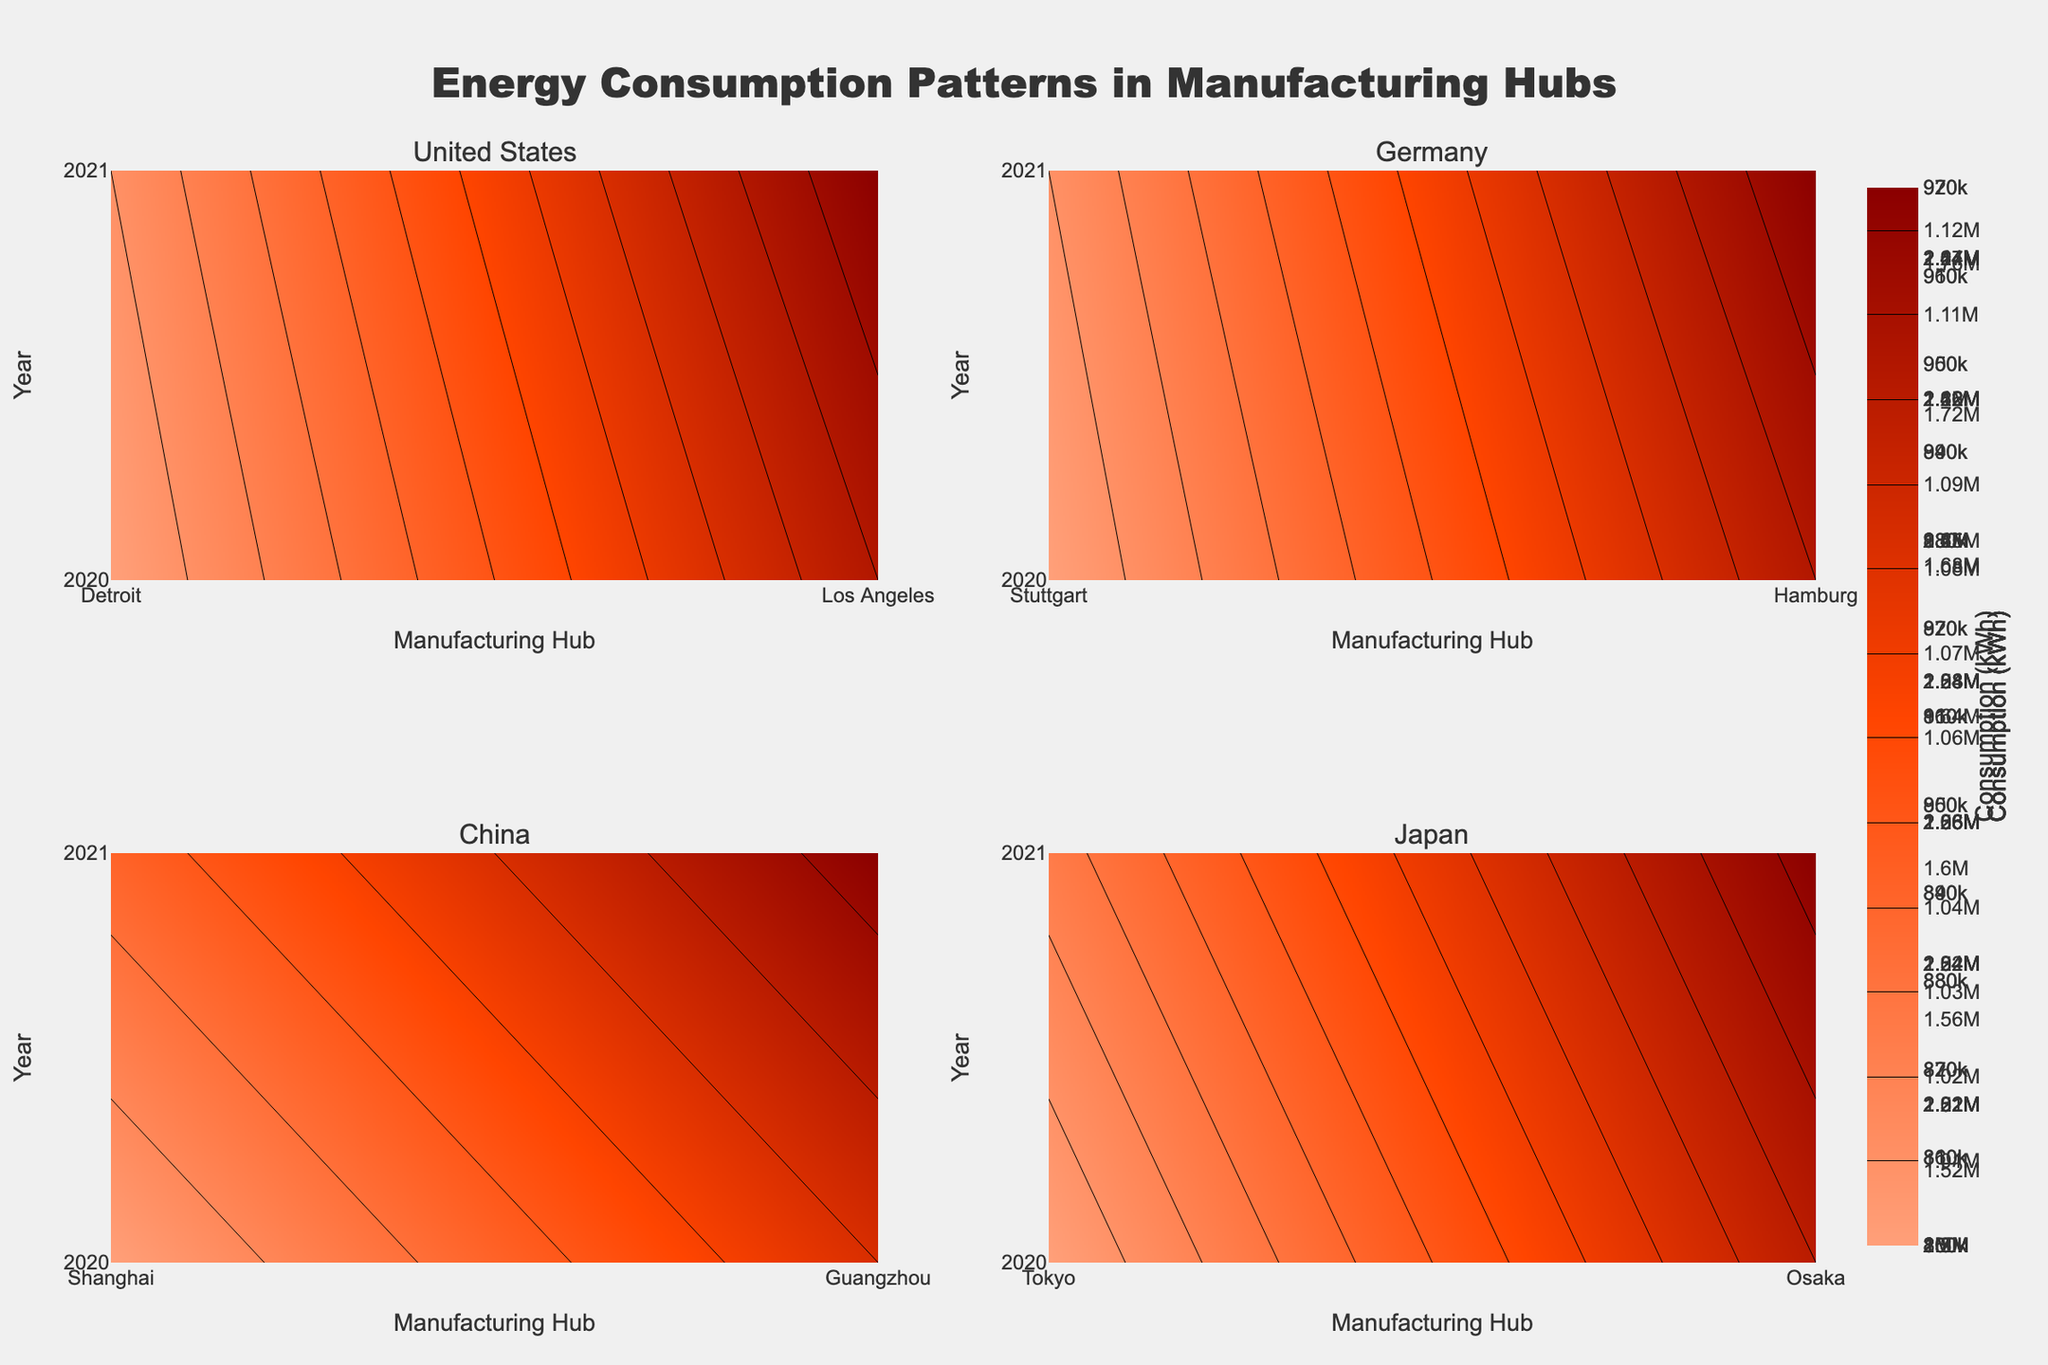What is the title of the figure? The title is located at the top of the figure. Based on its position and font, the title reads "Energy Consumption Patterns in Manufacturing Hubs".
Answer: Energy Consumption Patterns in Manufacturing Hubs Which energy source has a colorbar titled "Consumption (kWh)" in the heatmap? By observing the color scales and the name associated with each contour plot, it can be noted that both energy sources have similar colorbars for visual consistency. However, the colorbar title "Consumption (kWh)" applies to all energy sources displayed.
Answer: All energy sources Which country has the highest energy consumption in 2021 according to the figure? Identifying the contour levels for each country in 2021, it is clear that China, especially via Shanghai and Guangzhou hubs, shows the highest levels of energy consumption.
Answer: China (Shanghai, Guangzhou) How does the energy consumption in Detroit for Natural Gas in 2021 compare to 2020? Referring to the contour lines and their levels for the corresponding years, we observe Detroit's Natural Gas consumption in 2021 (810,000 kWh) is higher than in 2020 (800,000 kWh).
Answer: Higher in 2021 In which hub and year was the highest electricity consumption observed for Japan? By analyzing the highest contour levels for Japan, it is evident that Osaka in 2021 reaches the peak electricity consumption of 2,450,000 kWh.
Answer: Osaka, 2021 What are the x-axis and y-axis labels of the contour plots? Referring to both the bottom (x-axis) and left side (y-axis) of the plots, the x-axis label is "Manufacturing Hub", and the y-axis label is "Year".
Answer: Manufacturing Hub, Year Which hub in Germany had the highest annual average energy consumption in 2020 and 2021 considering both energy sources? Splitting each hub's energy consumption between Electricity and Natural Gas for both years and averaging them: Stuttgart (2,150,000+850,000+2,050,000+860,000) and Hamburg (2,100,000+950,000+2,150,000+970,000). Then averaging each sum and comparing: Hamburg averages higher.
Answer: Hamburg Compare the electricity consumption between Los Angeles and Stuttgart in 2021. Which one is higher? By checking the contour levels representing 2021, Los Angeles consumes 1,780,000 kWh while Stuttgart consumes 2,050,000 kWh. Stuttgart is higher.
Answer: Stuttgart What is the color pattern used to represent varying levels of energy consumption? Referring to the color scales on the contours, it progresses from lighter shades (e.g., light salmon) for lower consumption to darker shades (e.g., dark red) for higher consumption.
Answer: Light to dark shades (salmon to dark red) Between Shanghai and Tokyo, which hub showed a greater increase in natural gas consumption from 2020 to 2021? Evaluating the contour levels marking both years: Shanghai went from 1,200,000 kWh to 1,225,000 kWh (increase of 25,000 kWh), and Tokyo from 1,000,000 kWh to 1,025,000 kWh (increase of 25,000 kWh). Both increased by the same amount.
Answer: Equal Increase 